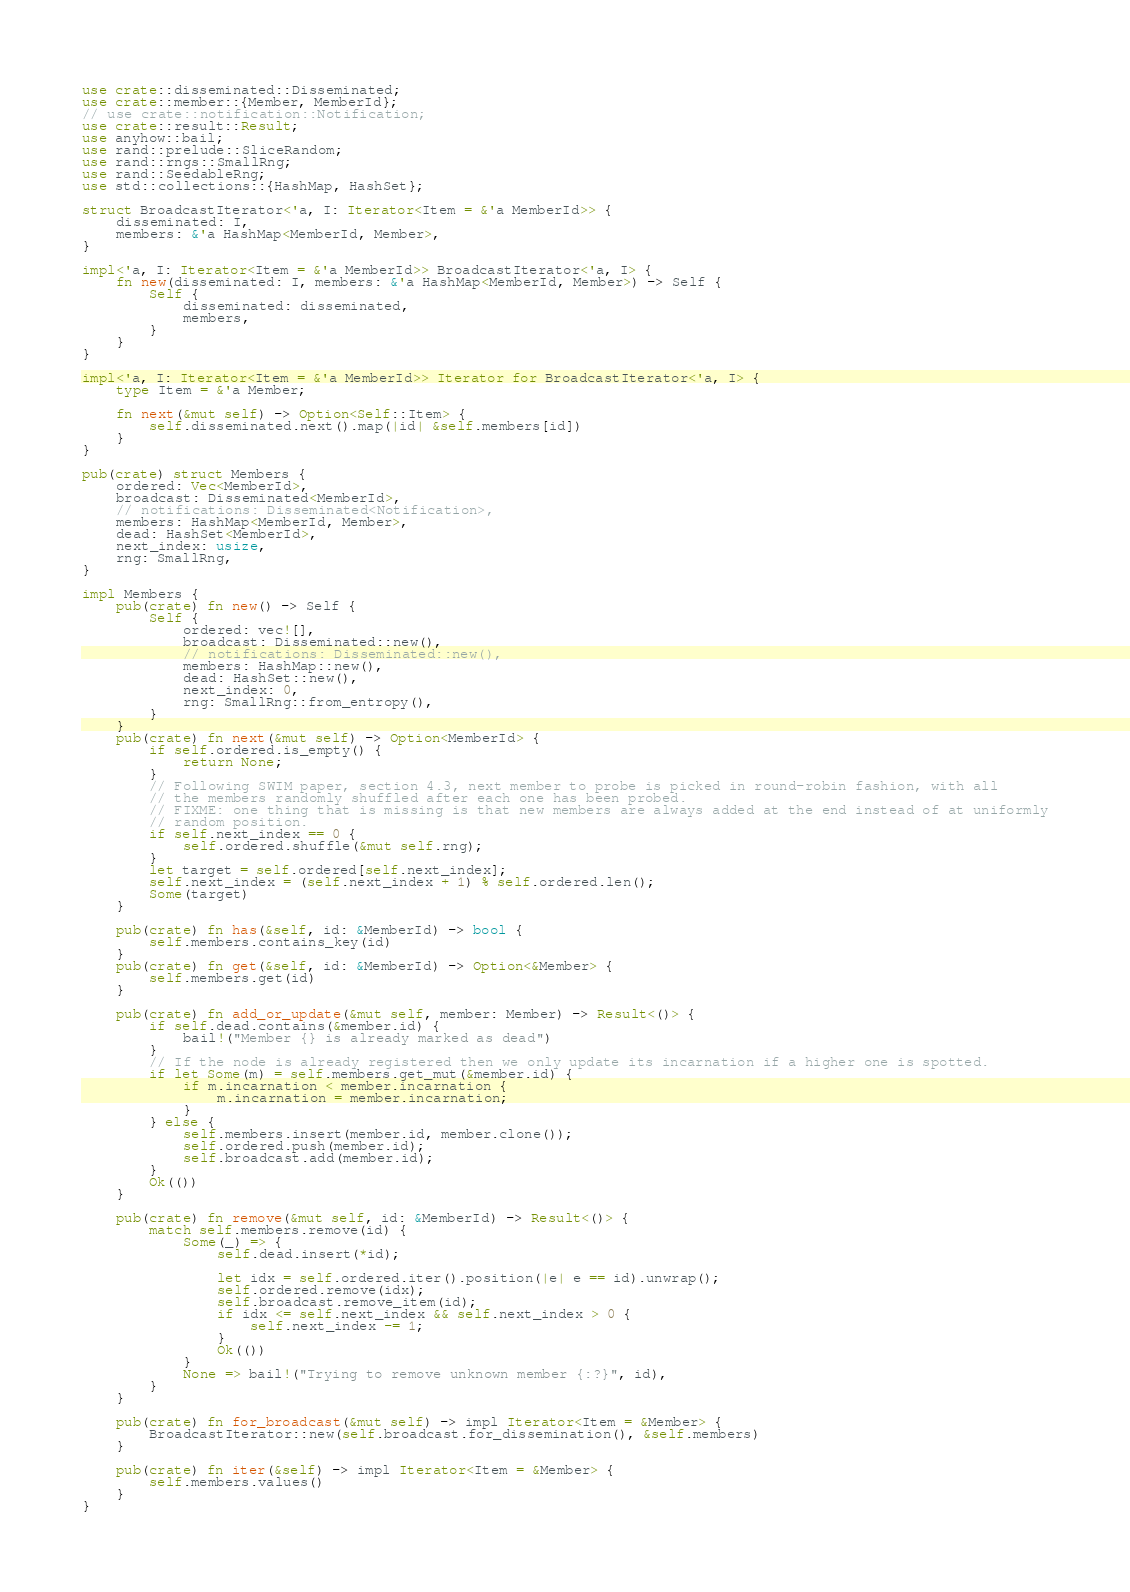Convert code to text. <code><loc_0><loc_0><loc_500><loc_500><_Rust_>use crate::disseminated::Disseminated;
use crate::member::{Member, MemberId};
// use crate::notification::Notification;
use crate::result::Result;
use anyhow::bail;
use rand::prelude::SliceRandom;
use rand::rngs::SmallRng;
use rand::SeedableRng;
use std::collections::{HashMap, HashSet};

struct BroadcastIterator<'a, I: Iterator<Item = &'a MemberId>> {
    disseminated: I,
    members: &'a HashMap<MemberId, Member>,
}

impl<'a, I: Iterator<Item = &'a MemberId>> BroadcastIterator<'a, I> {
    fn new(disseminated: I, members: &'a HashMap<MemberId, Member>) -> Self {
        Self {
            disseminated: disseminated,
            members,
        }
    }
}

impl<'a, I: Iterator<Item = &'a MemberId>> Iterator for BroadcastIterator<'a, I> {
    type Item = &'a Member;

    fn next(&mut self) -> Option<Self::Item> {
        self.disseminated.next().map(|id| &self.members[id])
    }
}

pub(crate) struct Members {
    ordered: Vec<MemberId>,
    broadcast: Disseminated<MemberId>,
    // notifications: Disseminated<Notification>,
    members: HashMap<MemberId, Member>,
    dead: HashSet<MemberId>,
    next_index: usize,
    rng: SmallRng,
}

impl Members {
    pub(crate) fn new() -> Self {
        Self {
            ordered: vec![],
            broadcast: Disseminated::new(),
            // notifications: Disseminated::new(),
            members: HashMap::new(),
            dead: HashSet::new(),
            next_index: 0,
            rng: SmallRng::from_entropy(),
        }
    }
    pub(crate) fn next(&mut self) -> Option<MemberId> {
        if self.ordered.is_empty() {
            return None;
        }
        // Following SWIM paper, section 4.3, next member to probe is picked in round-robin fashion, with all
        // the members randomly shuffled after each one has been probed.
        // FIXME: one thing that is missing is that new members are always added at the end instead of at uniformly
        // random position.
        if self.next_index == 0 {
            self.ordered.shuffle(&mut self.rng);
        }
        let target = self.ordered[self.next_index];
        self.next_index = (self.next_index + 1) % self.ordered.len();
        Some(target)
    }

    pub(crate) fn has(&self, id: &MemberId) -> bool {
        self.members.contains_key(id)
    }
    pub(crate) fn get(&self, id: &MemberId) -> Option<&Member> {
        self.members.get(id)
    }

    pub(crate) fn add_or_update(&mut self, member: Member) -> Result<()> {
        if self.dead.contains(&member.id) {
            bail!("Member {} is already marked as dead")
        }
        // If the node is already registered then we only update its incarnation if a higher one is spotted.
        if let Some(m) = self.members.get_mut(&member.id) {
            if m.incarnation < member.incarnation {
                m.incarnation = member.incarnation;
            }
        } else {
            self.members.insert(member.id, member.clone());
            self.ordered.push(member.id);
            self.broadcast.add(member.id);
        }
        Ok(())
    }

    pub(crate) fn remove(&mut self, id: &MemberId) -> Result<()> {
        match self.members.remove(id) {
            Some(_) => {
                self.dead.insert(*id);

                let idx = self.ordered.iter().position(|e| e == id).unwrap();
                self.ordered.remove(idx);
                self.broadcast.remove_item(id);
                if idx <= self.next_index && self.next_index > 0 {
                    self.next_index -= 1;
                }
                Ok(())
            }
            None => bail!("Trying to remove unknown member {:?}", id),
        }
    }

    pub(crate) fn for_broadcast(&mut self) -> impl Iterator<Item = &Member> {
        BroadcastIterator::new(self.broadcast.for_dissemination(), &self.members)
    }

    pub(crate) fn iter(&self) -> impl Iterator<Item = &Member> {
        self.members.values()
    }
}
</code> 